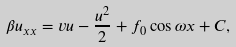<formula> <loc_0><loc_0><loc_500><loc_500>\beta u _ { x x } = v u - \frac { u ^ { 2 } } { 2 } + f _ { 0 } \cos \omega x + C ,</formula> 